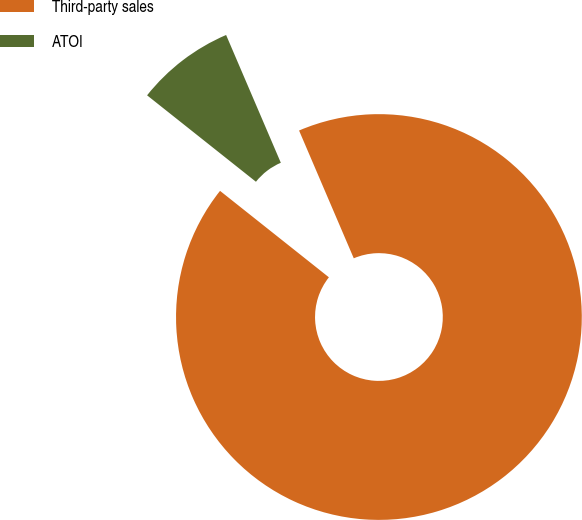Convert chart. <chart><loc_0><loc_0><loc_500><loc_500><pie_chart><fcel>Third-party sales<fcel>ATOI<nl><fcel>92.12%<fcel>7.88%<nl></chart> 